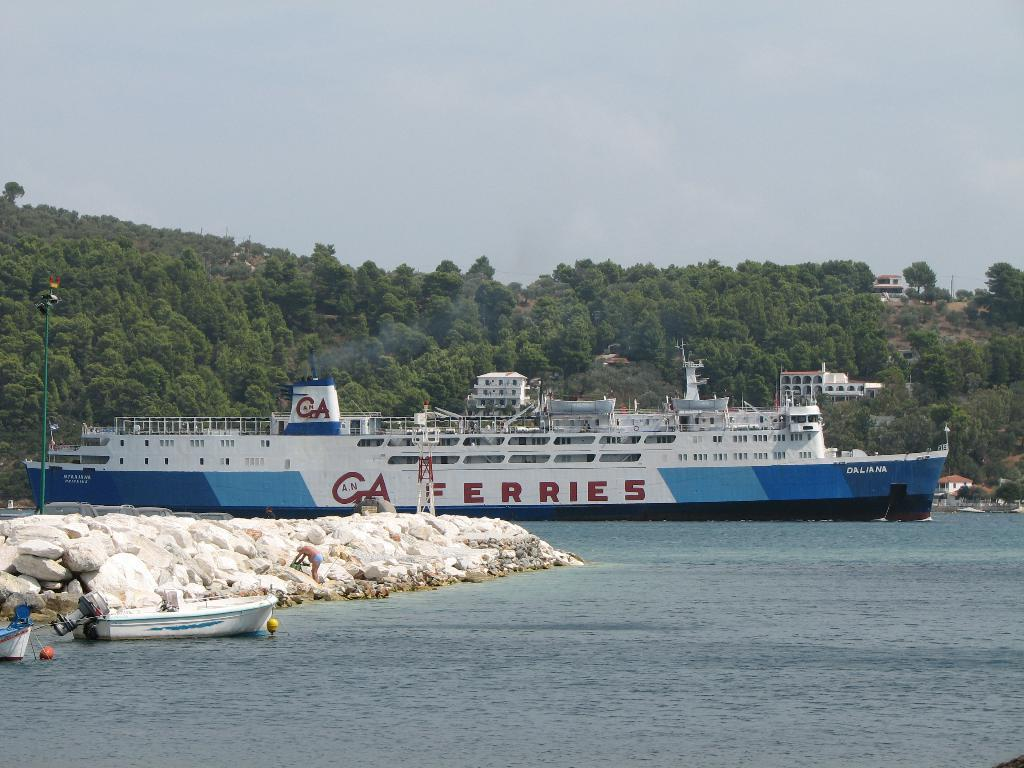What is the main subject of the image? The main subject of the image is a ship. Where is the ship located in the image? The ship is on the water. What other objects can be seen in the image? There are poles, trees, buildings, and the sky visible in the image. Can you describe the trees in the background? The trees in the background are green. How about the buildings? The buildings in the background are white. What is the color of the sky in the image? The sky is white in the image. How many boys are playing with a kite in the image? There are no boys or kites present in the image. 